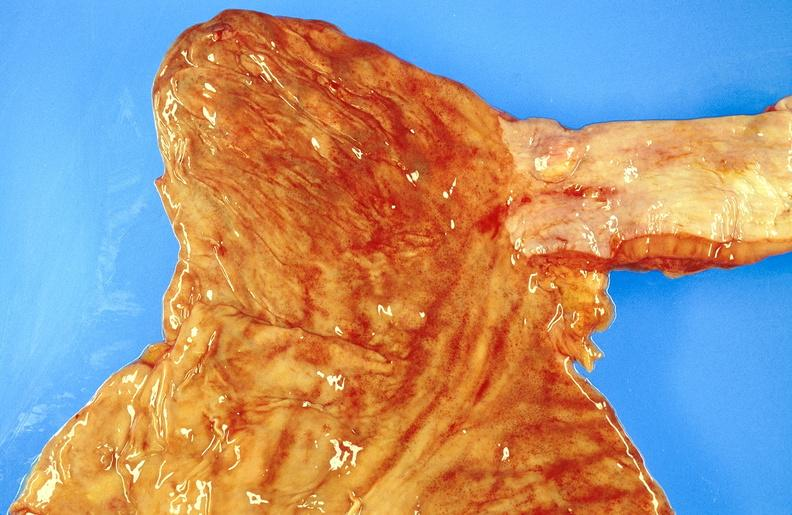what is present?
Answer the question using a single word or phrase. Gastrointestinal 